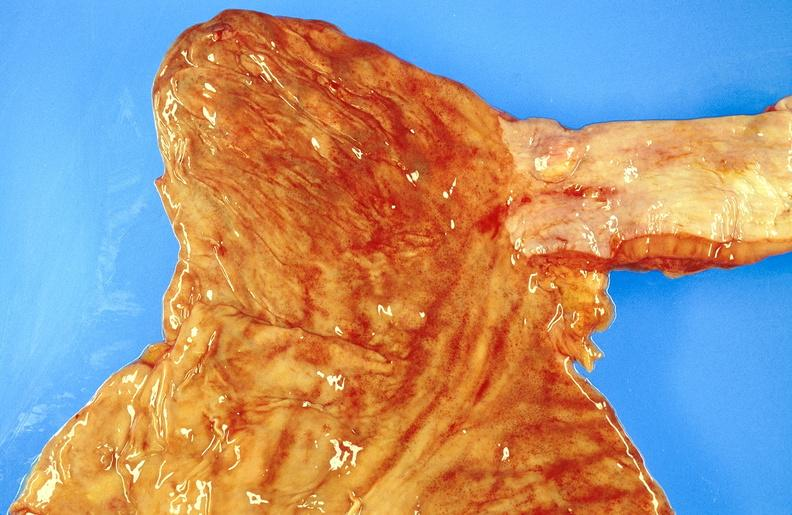what is present?
Answer the question using a single word or phrase. Gastrointestinal 